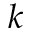<formula> <loc_0><loc_0><loc_500><loc_500>{ k }</formula> 